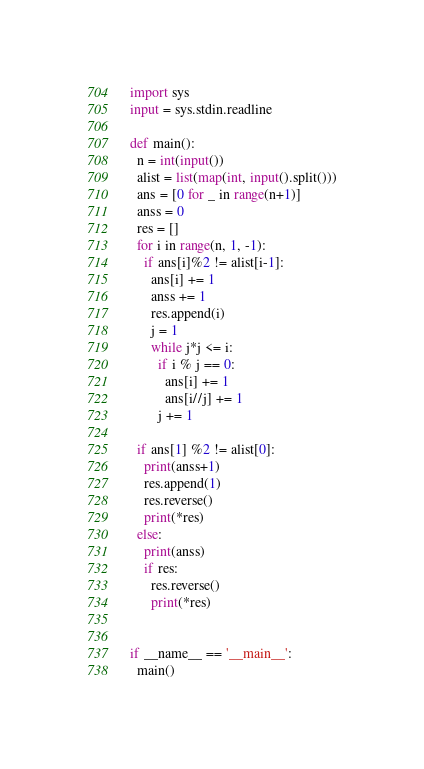<code> <loc_0><loc_0><loc_500><loc_500><_Python_>import sys
input = sys.stdin.readline

def main():
  n = int(input())
  alist = list(map(int, input().split()))
  ans = [0 for _ in range(n+1)]
  anss = 0
  res = []
  for i in range(n, 1, -1):
    if ans[i]%2 != alist[i-1]:
      ans[i] += 1
      anss += 1
      res.append(i)
      j = 1
      while j*j <= i:
        if i % j == 0:
          ans[i] += 1
          ans[i//j] += 1
        j += 1

  if ans[1] %2 != alist[0]:
    print(anss+1)
    res.append(1)
    res.reverse()
    print(*res)
  else:
    print(anss)
    if res:
      res.reverse()
      print(*res)


if __name__ == '__main__':
  main()
</code> 